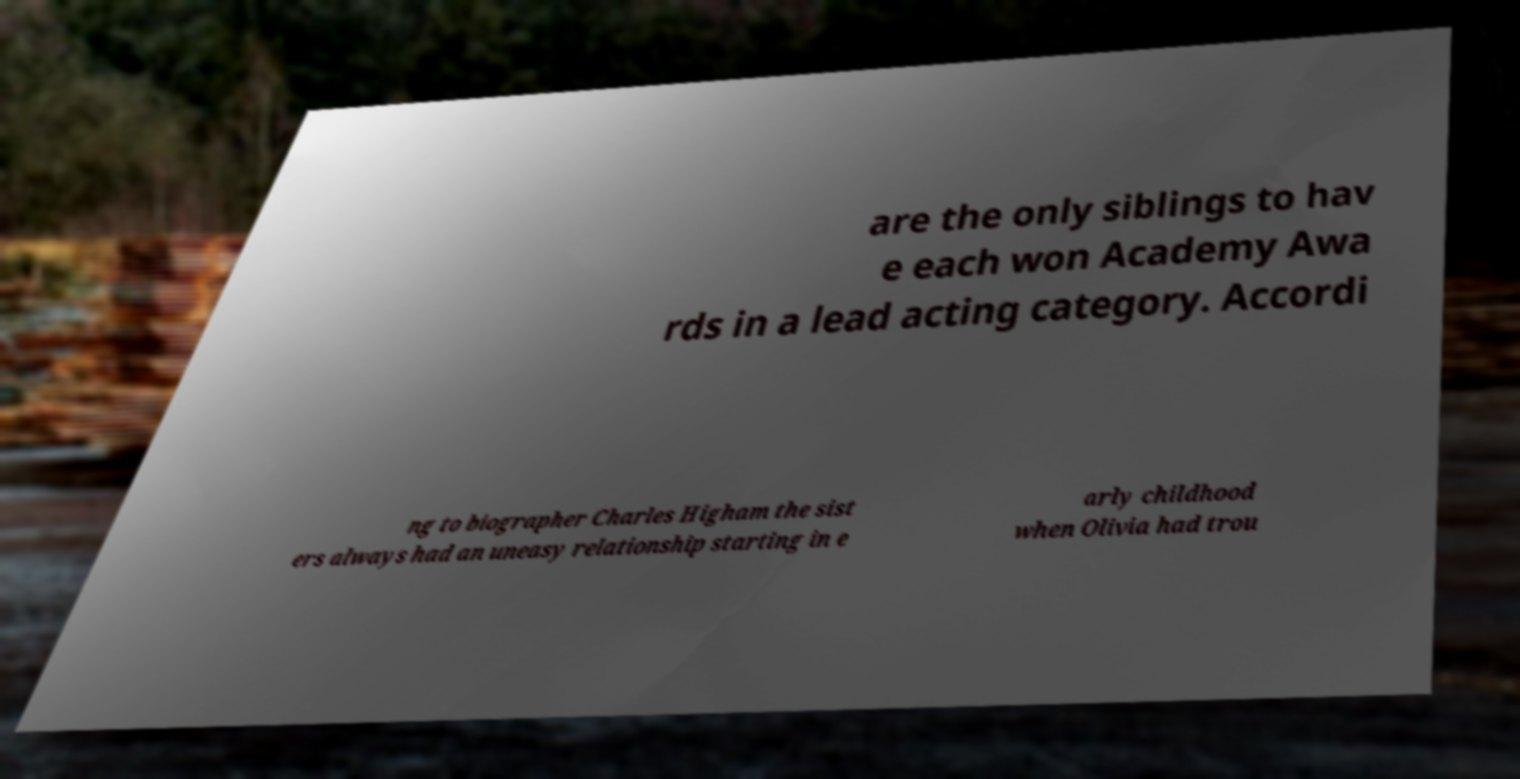Could you extract and type out the text from this image? are the only siblings to hav e each won Academy Awa rds in a lead acting category. Accordi ng to biographer Charles Higham the sist ers always had an uneasy relationship starting in e arly childhood when Olivia had trou 